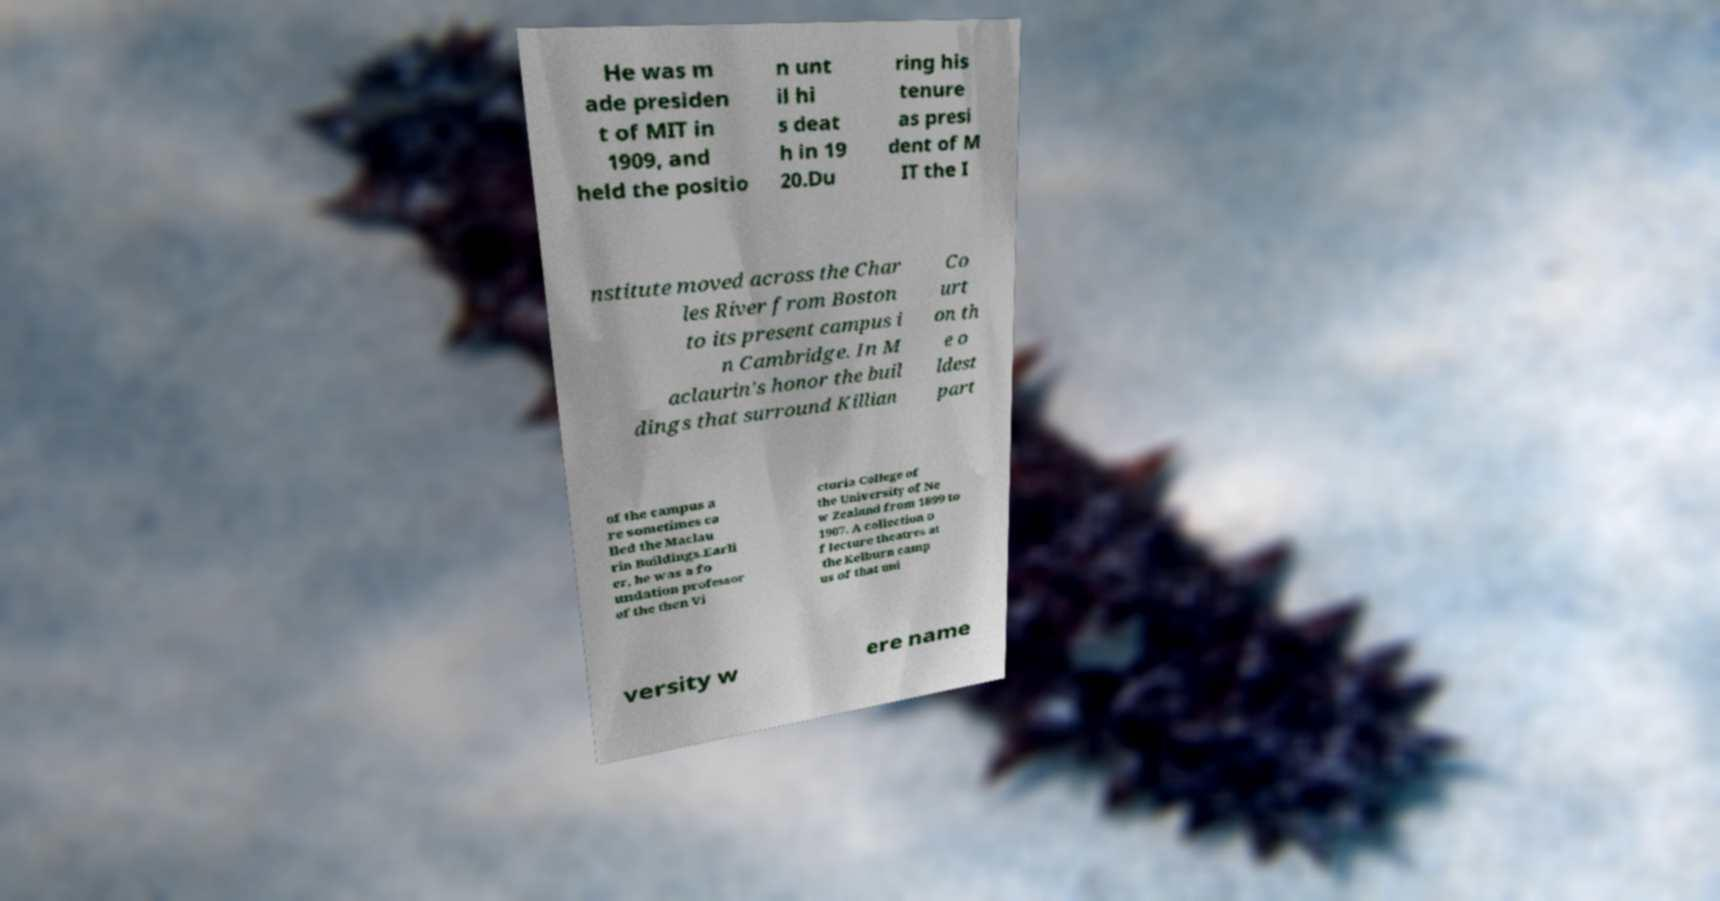Could you assist in decoding the text presented in this image and type it out clearly? He was m ade presiden t of MIT in 1909, and held the positio n unt il hi s deat h in 19 20.Du ring his tenure as presi dent of M IT the I nstitute moved across the Char les River from Boston to its present campus i n Cambridge. In M aclaurin's honor the buil dings that surround Killian Co urt on th e o ldest part of the campus a re sometimes ca lled the Maclau rin Buildings.Earli er, he was a fo undation professor of the then Vi ctoria College of the University of Ne w Zealand from 1899 to 1907. A collection o f lecture theatres at the Kelburn camp us of that uni versity w ere name 